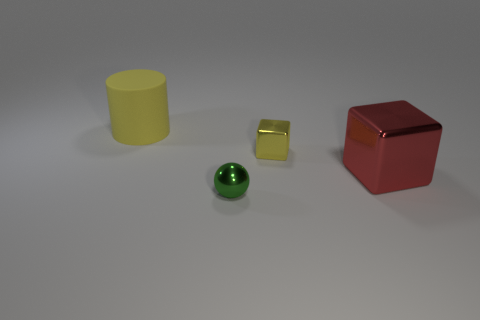Add 4 spheres. How many objects exist? 8 Subtract all balls. How many objects are left? 3 Add 4 big yellow cylinders. How many big yellow cylinders exist? 5 Subtract 0 green cubes. How many objects are left? 4 Subtract all red objects. Subtract all red metal things. How many objects are left? 2 Add 2 tiny yellow shiny things. How many tiny yellow shiny things are left? 3 